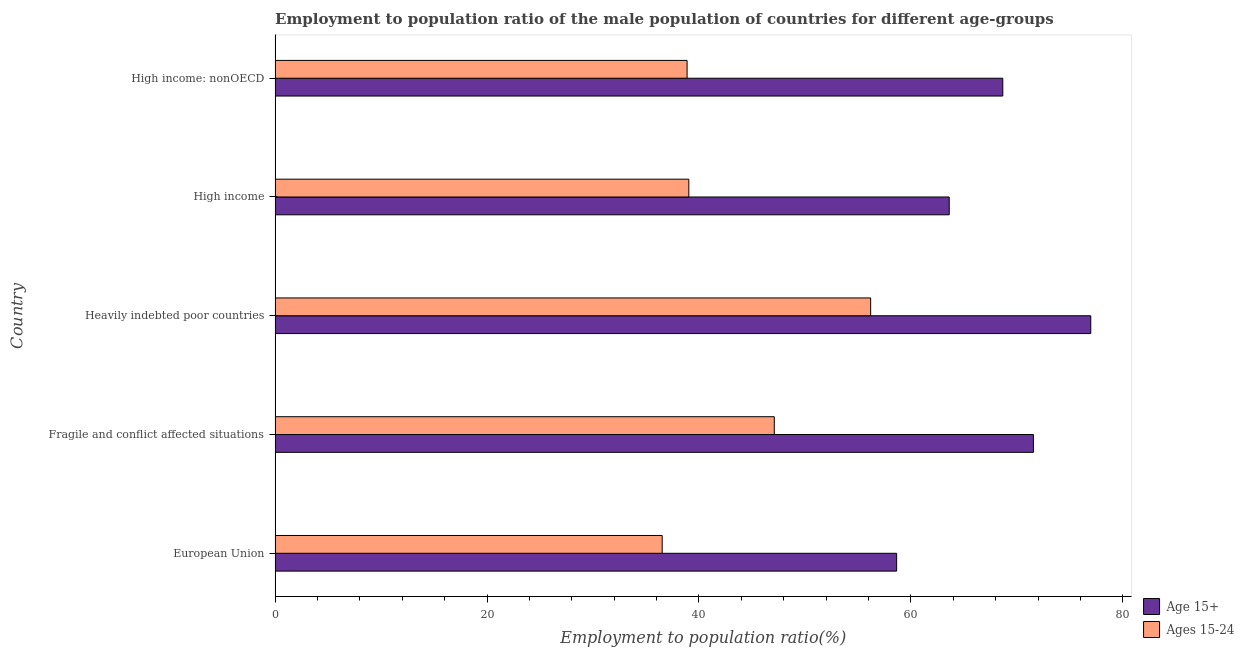How many different coloured bars are there?
Make the answer very short. 2. Are the number of bars on each tick of the Y-axis equal?
Keep it short and to the point. Yes. How many bars are there on the 3rd tick from the top?
Provide a succinct answer. 2. How many bars are there on the 4th tick from the bottom?
Ensure brevity in your answer.  2. What is the label of the 1st group of bars from the top?
Offer a terse response. High income: nonOECD. In how many cases, is the number of bars for a given country not equal to the number of legend labels?
Your response must be concise. 0. What is the employment to population ratio(age 15+) in European Union?
Provide a succinct answer. 58.66. Across all countries, what is the maximum employment to population ratio(age 15+)?
Your answer should be very brief. 76.98. Across all countries, what is the minimum employment to population ratio(age 15+)?
Offer a terse response. 58.66. In which country was the employment to population ratio(age 15-24) maximum?
Ensure brevity in your answer.  Heavily indebted poor countries. In which country was the employment to population ratio(age 15+) minimum?
Your response must be concise. European Union. What is the total employment to population ratio(age 15+) in the graph?
Your answer should be compact. 339.5. What is the difference between the employment to population ratio(age 15-24) in Fragile and conflict affected situations and that in High income?
Provide a short and direct response. 8.06. What is the difference between the employment to population ratio(age 15-24) in Heavily indebted poor countries and the employment to population ratio(age 15+) in Fragile and conflict affected situations?
Your answer should be compact. -15.36. What is the average employment to population ratio(age 15+) per country?
Provide a succinct answer. 67.9. What is the difference between the employment to population ratio(age 15-24) and employment to population ratio(age 15+) in Heavily indebted poor countries?
Keep it short and to the point. -20.77. What is the ratio of the employment to population ratio(age 15+) in Fragile and conflict affected situations to that in High income: nonOECD?
Provide a short and direct response. 1.04. Is the difference between the employment to population ratio(age 15-24) in Heavily indebted poor countries and High income greater than the difference between the employment to population ratio(age 15+) in Heavily indebted poor countries and High income?
Provide a short and direct response. Yes. What is the difference between the highest and the second highest employment to population ratio(age 15-24)?
Offer a very short reply. 9.09. What is the difference between the highest and the lowest employment to population ratio(age 15-24)?
Offer a terse response. 19.67. In how many countries, is the employment to population ratio(age 15-24) greater than the average employment to population ratio(age 15-24) taken over all countries?
Make the answer very short. 2. Is the sum of the employment to population ratio(age 15+) in European Union and Heavily indebted poor countries greater than the maximum employment to population ratio(age 15-24) across all countries?
Offer a terse response. Yes. What does the 1st bar from the top in Heavily indebted poor countries represents?
Your response must be concise. Ages 15-24. What does the 2nd bar from the bottom in European Union represents?
Ensure brevity in your answer.  Ages 15-24. Are all the bars in the graph horizontal?
Give a very brief answer. Yes. What is the difference between two consecutive major ticks on the X-axis?
Provide a short and direct response. 20. Are the values on the major ticks of X-axis written in scientific E-notation?
Your answer should be compact. No. Does the graph contain any zero values?
Your answer should be very brief. No. How are the legend labels stacked?
Ensure brevity in your answer.  Vertical. What is the title of the graph?
Provide a succinct answer. Employment to population ratio of the male population of countries for different age-groups. What is the label or title of the Y-axis?
Offer a terse response. Country. What is the Employment to population ratio(%) of Age 15+ in European Union?
Provide a short and direct response. 58.66. What is the Employment to population ratio(%) of Ages 15-24 in European Union?
Make the answer very short. 36.53. What is the Employment to population ratio(%) in Age 15+ in Fragile and conflict affected situations?
Give a very brief answer. 71.57. What is the Employment to population ratio(%) of Ages 15-24 in Fragile and conflict affected situations?
Offer a terse response. 47.11. What is the Employment to population ratio(%) in Age 15+ in Heavily indebted poor countries?
Offer a terse response. 76.98. What is the Employment to population ratio(%) of Ages 15-24 in Heavily indebted poor countries?
Ensure brevity in your answer.  56.21. What is the Employment to population ratio(%) in Age 15+ in High income?
Give a very brief answer. 63.62. What is the Employment to population ratio(%) of Ages 15-24 in High income?
Your answer should be compact. 39.05. What is the Employment to population ratio(%) of Age 15+ in High income: nonOECD?
Offer a terse response. 68.68. What is the Employment to population ratio(%) in Ages 15-24 in High income: nonOECD?
Give a very brief answer. 38.88. Across all countries, what is the maximum Employment to population ratio(%) of Age 15+?
Offer a very short reply. 76.98. Across all countries, what is the maximum Employment to population ratio(%) in Ages 15-24?
Your answer should be compact. 56.21. Across all countries, what is the minimum Employment to population ratio(%) in Age 15+?
Give a very brief answer. 58.66. Across all countries, what is the minimum Employment to population ratio(%) in Ages 15-24?
Provide a short and direct response. 36.53. What is the total Employment to population ratio(%) of Age 15+ in the graph?
Give a very brief answer. 339.5. What is the total Employment to population ratio(%) of Ages 15-24 in the graph?
Offer a terse response. 217.78. What is the difference between the Employment to population ratio(%) in Age 15+ in European Union and that in Fragile and conflict affected situations?
Make the answer very short. -12.91. What is the difference between the Employment to population ratio(%) of Ages 15-24 in European Union and that in Fragile and conflict affected situations?
Keep it short and to the point. -10.58. What is the difference between the Employment to population ratio(%) in Age 15+ in European Union and that in Heavily indebted poor countries?
Provide a succinct answer. -18.32. What is the difference between the Employment to population ratio(%) of Ages 15-24 in European Union and that in Heavily indebted poor countries?
Your answer should be compact. -19.67. What is the difference between the Employment to population ratio(%) in Age 15+ in European Union and that in High income?
Ensure brevity in your answer.  -4.96. What is the difference between the Employment to population ratio(%) in Ages 15-24 in European Union and that in High income?
Provide a short and direct response. -2.51. What is the difference between the Employment to population ratio(%) of Age 15+ in European Union and that in High income: nonOECD?
Ensure brevity in your answer.  -10.02. What is the difference between the Employment to population ratio(%) of Ages 15-24 in European Union and that in High income: nonOECD?
Your response must be concise. -2.35. What is the difference between the Employment to population ratio(%) in Age 15+ in Fragile and conflict affected situations and that in Heavily indebted poor countries?
Provide a short and direct response. -5.41. What is the difference between the Employment to population ratio(%) of Ages 15-24 in Fragile and conflict affected situations and that in Heavily indebted poor countries?
Keep it short and to the point. -9.09. What is the difference between the Employment to population ratio(%) in Age 15+ in Fragile and conflict affected situations and that in High income?
Give a very brief answer. 7.95. What is the difference between the Employment to population ratio(%) of Ages 15-24 in Fragile and conflict affected situations and that in High income?
Make the answer very short. 8.07. What is the difference between the Employment to population ratio(%) in Age 15+ in Fragile and conflict affected situations and that in High income: nonOECD?
Offer a very short reply. 2.89. What is the difference between the Employment to population ratio(%) in Ages 15-24 in Fragile and conflict affected situations and that in High income: nonOECD?
Give a very brief answer. 8.23. What is the difference between the Employment to population ratio(%) in Age 15+ in Heavily indebted poor countries and that in High income?
Provide a succinct answer. 13.36. What is the difference between the Employment to population ratio(%) in Ages 15-24 in Heavily indebted poor countries and that in High income?
Provide a short and direct response. 17.16. What is the difference between the Employment to population ratio(%) in Age 15+ in Heavily indebted poor countries and that in High income: nonOECD?
Offer a very short reply. 8.3. What is the difference between the Employment to population ratio(%) of Ages 15-24 in Heavily indebted poor countries and that in High income: nonOECD?
Your answer should be compact. 17.32. What is the difference between the Employment to population ratio(%) of Age 15+ in High income and that in High income: nonOECD?
Give a very brief answer. -5.06. What is the difference between the Employment to population ratio(%) of Ages 15-24 in High income and that in High income: nonOECD?
Your response must be concise. 0.16. What is the difference between the Employment to population ratio(%) of Age 15+ in European Union and the Employment to population ratio(%) of Ages 15-24 in Fragile and conflict affected situations?
Provide a succinct answer. 11.55. What is the difference between the Employment to population ratio(%) of Age 15+ in European Union and the Employment to population ratio(%) of Ages 15-24 in Heavily indebted poor countries?
Make the answer very short. 2.45. What is the difference between the Employment to population ratio(%) of Age 15+ in European Union and the Employment to population ratio(%) of Ages 15-24 in High income?
Your response must be concise. 19.61. What is the difference between the Employment to population ratio(%) in Age 15+ in European Union and the Employment to population ratio(%) in Ages 15-24 in High income: nonOECD?
Provide a succinct answer. 19.78. What is the difference between the Employment to population ratio(%) of Age 15+ in Fragile and conflict affected situations and the Employment to population ratio(%) of Ages 15-24 in Heavily indebted poor countries?
Make the answer very short. 15.36. What is the difference between the Employment to population ratio(%) in Age 15+ in Fragile and conflict affected situations and the Employment to population ratio(%) in Ages 15-24 in High income?
Provide a succinct answer. 32.52. What is the difference between the Employment to population ratio(%) in Age 15+ in Fragile and conflict affected situations and the Employment to population ratio(%) in Ages 15-24 in High income: nonOECD?
Ensure brevity in your answer.  32.68. What is the difference between the Employment to population ratio(%) in Age 15+ in Heavily indebted poor countries and the Employment to population ratio(%) in Ages 15-24 in High income?
Provide a short and direct response. 37.93. What is the difference between the Employment to population ratio(%) of Age 15+ in Heavily indebted poor countries and the Employment to population ratio(%) of Ages 15-24 in High income: nonOECD?
Make the answer very short. 38.1. What is the difference between the Employment to population ratio(%) in Age 15+ in High income and the Employment to population ratio(%) in Ages 15-24 in High income: nonOECD?
Offer a very short reply. 24.74. What is the average Employment to population ratio(%) in Age 15+ per country?
Ensure brevity in your answer.  67.9. What is the average Employment to population ratio(%) of Ages 15-24 per country?
Offer a very short reply. 43.56. What is the difference between the Employment to population ratio(%) of Age 15+ and Employment to population ratio(%) of Ages 15-24 in European Union?
Offer a very short reply. 22.13. What is the difference between the Employment to population ratio(%) in Age 15+ and Employment to population ratio(%) in Ages 15-24 in Fragile and conflict affected situations?
Keep it short and to the point. 24.45. What is the difference between the Employment to population ratio(%) of Age 15+ and Employment to population ratio(%) of Ages 15-24 in Heavily indebted poor countries?
Give a very brief answer. 20.77. What is the difference between the Employment to population ratio(%) of Age 15+ and Employment to population ratio(%) of Ages 15-24 in High income?
Provide a succinct answer. 24.57. What is the difference between the Employment to population ratio(%) in Age 15+ and Employment to population ratio(%) in Ages 15-24 in High income: nonOECD?
Your answer should be compact. 29.79. What is the ratio of the Employment to population ratio(%) in Age 15+ in European Union to that in Fragile and conflict affected situations?
Your answer should be compact. 0.82. What is the ratio of the Employment to population ratio(%) in Ages 15-24 in European Union to that in Fragile and conflict affected situations?
Make the answer very short. 0.78. What is the ratio of the Employment to population ratio(%) of Age 15+ in European Union to that in Heavily indebted poor countries?
Your response must be concise. 0.76. What is the ratio of the Employment to population ratio(%) in Ages 15-24 in European Union to that in Heavily indebted poor countries?
Offer a terse response. 0.65. What is the ratio of the Employment to population ratio(%) of Age 15+ in European Union to that in High income?
Provide a succinct answer. 0.92. What is the ratio of the Employment to population ratio(%) of Ages 15-24 in European Union to that in High income?
Your response must be concise. 0.94. What is the ratio of the Employment to population ratio(%) of Age 15+ in European Union to that in High income: nonOECD?
Offer a terse response. 0.85. What is the ratio of the Employment to population ratio(%) in Ages 15-24 in European Union to that in High income: nonOECD?
Your response must be concise. 0.94. What is the ratio of the Employment to population ratio(%) in Age 15+ in Fragile and conflict affected situations to that in Heavily indebted poor countries?
Your response must be concise. 0.93. What is the ratio of the Employment to population ratio(%) in Ages 15-24 in Fragile and conflict affected situations to that in Heavily indebted poor countries?
Give a very brief answer. 0.84. What is the ratio of the Employment to population ratio(%) in Age 15+ in Fragile and conflict affected situations to that in High income?
Your answer should be very brief. 1.12. What is the ratio of the Employment to population ratio(%) in Ages 15-24 in Fragile and conflict affected situations to that in High income?
Your answer should be compact. 1.21. What is the ratio of the Employment to population ratio(%) of Age 15+ in Fragile and conflict affected situations to that in High income: nonOECD?
Ensure brevity in your answer.  1.04. What is the ratio of the Employment to population ratio(%) of Ages 15-24 in Fragile and conflict affected situations to that in High income: nonOECD?
Offer a terse response. 1.21. What is the ratio of the Employment to population ratio(%) in Age 15+ in Heavily indebted poor countries to that in High income?
Provide a succinct answer. 1.21. What is the ratio of the Employment to population ratio(%) of Ages 15-24 in Heavily indebted poor countries to that in High income?
Provide a succinct answer. 1.44. What is the ratio of the Employment to population ratio(%) of Age 15+ in Heavily indebted poor countries to that in High income: nonOECD?
Your answer should be compact. 1.12. What is the ratio of the Employment to population ratio(%) of Ages 15-24 in Heavily indebted poor countries to that in High income: nonOECD?
Make the answer very short. 1.45. What is the ratio of the Employment to population ratio(%) of Age 15+ in High income to that in High income: nonOECD?
Offer a very short reply. 0.93. What is the ratio of the Employment to population ratio(%) in Ages 15-24 in High income to that in High income: nonOECD?
Ensure brevity in your answer.  1. What is the difference between the highest and the second highest Employment to population ratio(%) in Age 15+?
Offer a terse response. 5.41. What is the difference between the highest and the second highest Employment to population ratio(%) in Ages 15-24?
Provide a short and direct response. 9.09. What is the difference between the highest and the lowest Employment to population ratio(%) in Age 15+?
Offer a terse response. 18.32. What is the difference between the highest and the lowest Employment to population ratio(%) in Ages 15-24?
Offer a terse response. 19.67. 